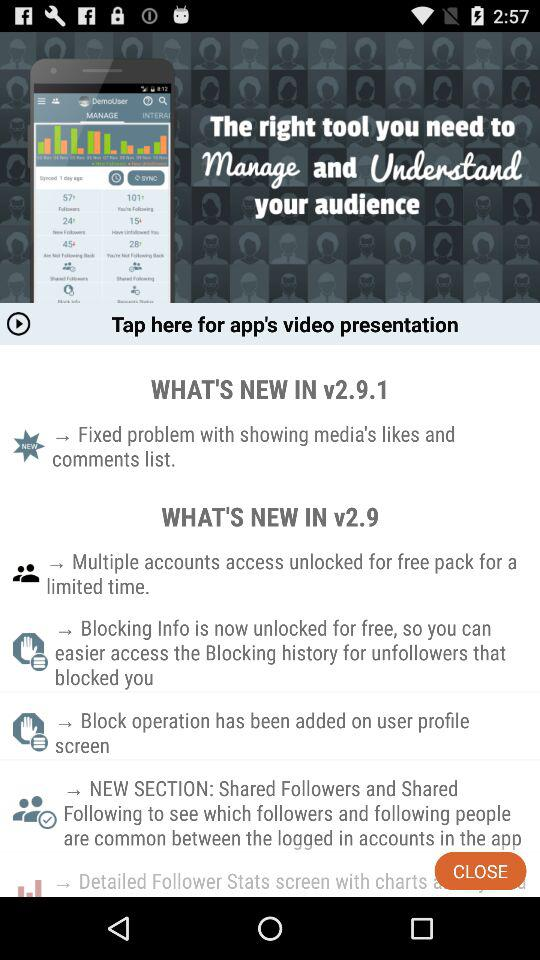In which version was the problem with showing the media's likes and comments list fixed? The version is v2.9.1. 